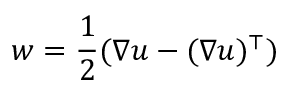Convert formula to latex. <formula><loc_0><loc_0><loc_500><loc_500>w = \frac { 1 } { 2 } ( \nabla u - ( \nabla u ) ^ { \top } )</formula> 